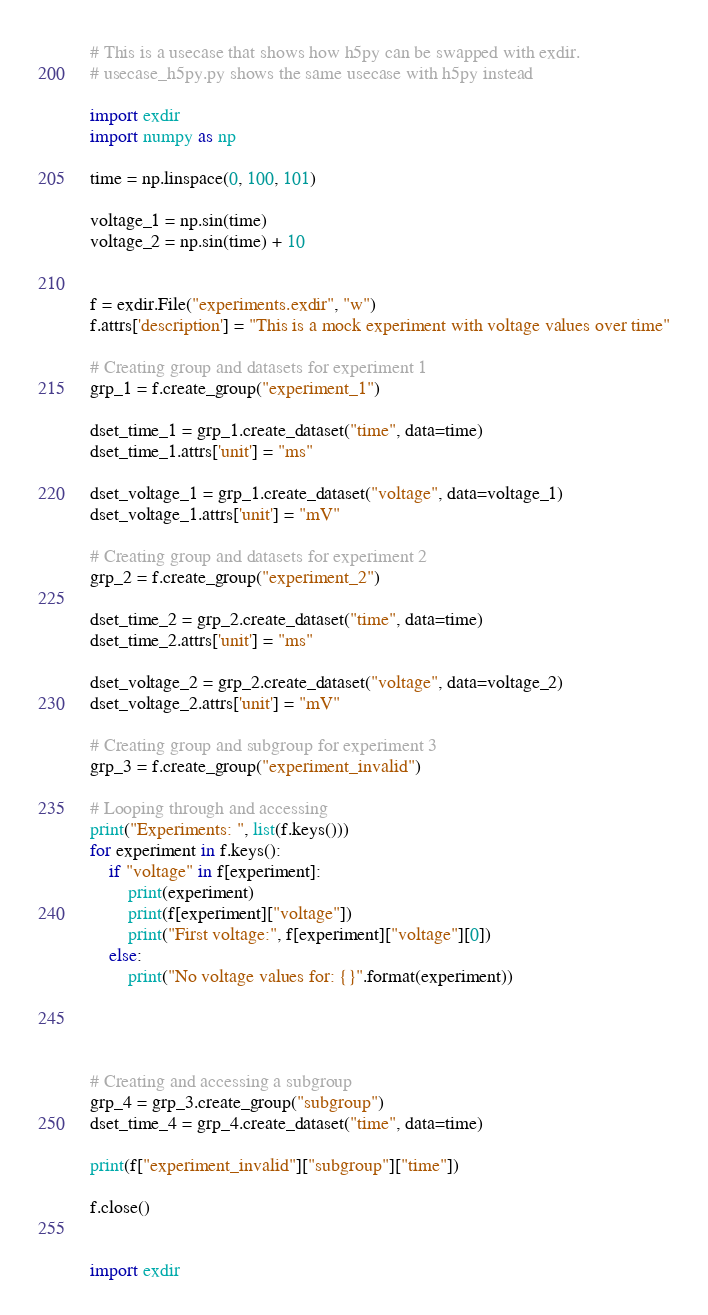Convert code to text. <code><loc_0><loc_0><loc_500><loc_500><_Python_># This is a usecase that shows how h5py can be swapped with exdir.
# usecase_h5py.py shows the same usecase with h5py instead

import exdir
import numpy as np

time = np.linspace(0, 100, 101)

voltage_1 = np.sin(time)
voltage_2 = np.sin(time) + 10


f = exdir.File("experiments.exdir", "w")
f.attrs['description'] = "This is a mock experiment with voltage values over time"

# Creating group and datasets for experiment 1
grp_1 = f.create_group("experiment_1")

dset_time_1 = grp_1.create_dataset("time", data=time)
dset_time_1.attrs['unit'] = "ms"

dset_voltage_1 = grp_1.create_dataset("voltage", data=voltage_1)
dset_voltage_1.attrs['unit'] = "mV"

# Creating group and datasets for experiment 2
grp_2 = f.create_group("experiment_2")

dset_time_2 = grp_2.create_dataset("time", data=time)
dset_time_2.attrs['unit'] = "ms"

dset_voltage_2 = grp_2.create_dataset("voltage", data=voltage_2)
dset_voltage_2.attrs['unit'] = "mV"

# Creating group and subgroup for experiment 3
grp_3 = f.create_group("experiment_invalid")

# Looping through and accessing
print("Experiments: ", list(f.keys()))
for experiment in f.keys():
    if "voltage" in f[experiment]:
        print(experiment)
        print(f[experiment]["voltage"])
        print("First voltage:", f[experiment]["voltage"][0])
    else:
        print("No voltage values for: {}".format(experiment))




# Creating and accessing a subgroup
grp_4 = grp_3.create_group("subgroup")
dset_time_4 = grp_4.create_dataset("time", data=time)

print(f["experiment_invalid"]["subgroup"]["time"])

f.close()


import exdir</code> 